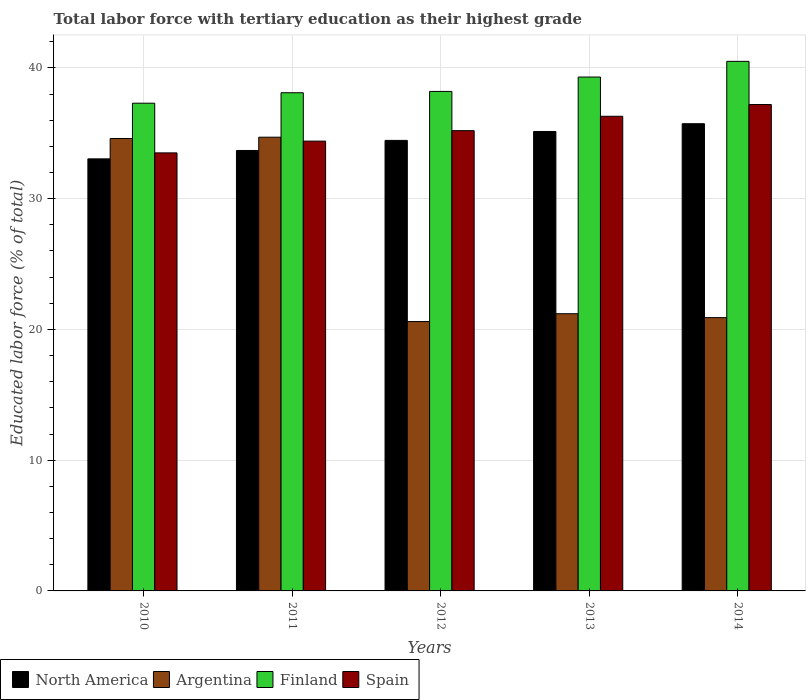How many groups of bars are there?
Keep it short and to the point. 5. Are the number of bars per tick equal to the number of legend labels?
Offer a terse response. Yes. How many bars are there on the 5th tick from the left?
Offer a terse response. 4. How many bars are there on the 3rd tick from the right?
Provide a short and direct response. 4. What is the label of the 3rd group of bars from the left?
Make the answer very short. 2012. What is the percentage of male labor force with tertiary education in North America in 2010?
Ensure brevity in your answer.  33.04. Across all years, what is the maximum percentage of male labor force with tertiary education in North America?
Provide a short and direct response. 35.73. Across all years, what is the minimum percentage of male labor force with tertiary education in North America?
Provide a short and direct response. 33.04. In which year was the percentage of male labor force with tertiary education in Finland minimum?
Make the answer very short. 2010. What is the total percentage of male labor force with tertiary education in North America in the graph?
Offer a terse response. 172.05. What is the difference between the percentage of male labor force with tertiary education in North America in 2010 and that in 2014?
Your response must be concise. -2.69. What is the difference between the percentage of male labor force with tertiary education in Finland in 2010 and the percentage of male labor force with tertiary education in Argentina in 2014?
Offer a terse response. 16.4. What is the average percentage of male labor force with tertiary education in Spain per year?
Your response must be concise. 35.32. In the year 2011, what is the difference between the percentage of male labor force with tertiary education in Argentina and percentage of male labor force with tertiary education in North America?
Offer a very short reply. 1.02. What is the ratio of the percentage of male labor force with tertiary education in Argentina in 2011 to that in 2012?
Give a very brief answer. 1.68. Is the percentage of male labor force with tertiary education in Spain in 2012 less than that in 2014?
Keep it short and to the point. Yes. Is the difference between the percentage of male labor force with tertiary education in Argentina in 2010 and 2012 greater than the difference between the percentage of male labor force with tertiary education in North America in 2010 and 2012?
Provide a short and direct response. Yes. What is the difference between the highest and the second highest percentage of male labor force with tertiary education in Argentina?
Provide a short and direct response. 0.1. What is the difference between the highest and the lowest percentage of male labor force with tertiary education in Argentina?
Make the answer very short. 14.1. In how many years, is the percentage of male labor force with tertiary education in Spain greater than the average percentage of male labor force with tertiary education in Spain taken over all years?
Give a very brief answer. 2. Is the sum of the percentage of male labor force with tertiary education in Finland in 2010 and 2011 greater than the maximum percentage of male labor force with tertiary education in Spain across all years?
Your answer should be compact. Yes. Is it the case that in every year, the sum of the percentage of male labor force with tertiary education in North America and percentage of male labor force with tertiary education in Finland is greater than the sum of percentage of male labor force with tertiary education in Spain and percentage of male labor force with tertiary education in Argentina?
Your answer should be very brief. Yes. What does the 2nd bar from the left in 2011 represents?
Provide a succinct answer. Argentina. Is it the case that in every year, the sum of the percentage of male labor force with tertiary education in Spain and percentage of male labor force with tertiary education in Argentina is greater than the percentage of male labor force with tertiary education in North America?
Give a very brief answer. Yes. How many bars are there?
Make the answer very short. 20. Are all the bars in the graph horizontal?
Make the answer very short. No. Are the values on the major ticks of Y-axis written in scientific E-notation?
Offer a terse response. No. Does the graph contain any zero values?
Make the answer very short. No. Where does the legend appear in the graph?
Offer a terse response. Bottom left. What is the title of the graph?
Your response must be concise. Total labor force with tertiary education as their highest grade. What is the label or title of the X-axis?
Provide a short and direct response. Years. What is the label or title of the Y-axis?
Your response must be concise. Educated labor force (% of total). What is the Educated labor force (% of total) of North America in 2010?
Provide a succinct answer. 33.04. What is the Educated labor force (% of total) in Argentina in 2010?
Offer a terse response. 34.6. What is the Educated labor force (% of total) in Finland in 2010?
Keep it short and to the point. 37.3. What is the Educated labor force (% of total) in Spain in 2010?
Offer a terse response. 33.5. What is the Educated labor force (% of total) of North America in 2011?
Offer a very short reply. 33.68. What is the Educated labor force (% of total) of Argentina in 2011?
Offer a very short reply. 34.7. What is the Educated labor force (% of total) in Finland in 2011?
Ensure brevity in your answer.  38.1. What is the Educated labor force (% of total) in Spain in 2011?
Ensure brevity in your answer.  34.4. What is the Educated labor force (% of total) in North America in 2012?
Make the answer very short. 34.45. What is the Educated labor force (% of total) in Argentina in 2012?
Your response must be concise. 20.6. What is the Educated labor force (% of total) in Finland in 2012?
Offer a terse response. 38.2. What is the Educated labor force (% of total) of Spain in 2012?
Ensure brevity in your answer.  35.2. What is the Educated labor force (% of total) in North America in 2013?
Your response must be concise. 35.14. What is the Educated labor force (% of total) of Argentina in 2013?
Your response must be concise. 21.2. What is the Educated labor force (% of total) in Finland in 2013?
Keep it short and to the point. 39.3. What is the Educated labor force (% of total) of Spain in 2013?
Your answer should be compact. 36.3. What is the Educated labor force (% of total) in North America in 2014?
Ensure brevity in your answer.  35.73. What is the Educated labor force (% of total) in Argentina in 2014?
Give a very brief answer. 20.9. What is the Educated labor force (% of total) in Finland in 2014?
Keep it short and to the point. 40.5. What is the Educated labor force (% of total) in Spain in 2014?
Your response must be concise. 37.2. Across all years, what is the maximum Educated labor force (% of total) of North America?
Give a very brief answer. 35.73. Across all years, what is the maximum Educated labor force (% of total) of Argentina?
Offer a very short reply. 34.7. Across all years, what is the maximum Educated labor force (% of total) in Finland?
Provide a succinct answer. 40.5. Across all years, what is the maximum Educated labor force (% of total) in Spain?
Offer a terse response. 37.2. Across all years, what is the minimum Educated labor force (% of total) in North America?
Give a very brief answer. 33.04. Across all years, what is the minimum Educated labor force (% of total) in Argentina?
Provide a short and direct response. 20.6. Across all years, what is the minimum Educated labor force (% of total) of Finland?
Ensure brevity in your answer.  37.3. Across all years, what is the minimum Educated labor force (% of total) in Spain?
Keep it short and to the point. 33.5. What is the total Educated labor force (% of total) of North America in the graph?
Offer a terse response. 172.05. What is the total Educated labor force (% of total) in Argentina in the graph?
Make the answer very short. 132. What is the total Educated labor force (% of total) in Finland in the graph?
Your answer should be very brief. 193.4. What is the total Educated labor force (% of total) in Spain in the graph?
Offer a very short reply. 176.6. What is the difference between the Educated labor force (% of total) in North America in 2010 and that in 2011?
Your answer should be very brief. -0.64. What is the difference between the Educated labor force (% of total) of North America in 2010 and that in 2012?
Offer a very short reply. -1.41. What is the difference between the Educated labor force (% of total) of Finland in 2010 and that in 2012?
Offer a very short reply. -0.9. What is the difference between the Educated labor force (% of total) of North America in 2010 and that in 2013?
Provide a short and direct response. -2.09. What is the difference between the Educated labor force (% of total) of Argentina in 2010 and that in 2013?
Give a very brief answer. 13.4. What is the difference between the Educated labor force (% of total) of Finland in 2010 and that in 2013?
Give a very brief answer. -2. What is the difference between the Educated labor force (% of total) of Spain in 2010 and that in 2013?
Ensure brevity in your answer.  -2.8. What is the difference between the Educated labor force (% of total) in North America in 2010 and that in 2014?
Provide a short and direct response. -2.69. What is the difference between the Educated labor force (% of total) of North America in 2011 and that in 2012?
Provide a succinct answer. -0.77. What is the difference between the Educated labor force (% of total) of Argentina in 2011 and that in 2012?
Offer a very short reply. 14.1. What is the difference between the Educated labor force (% of total) of Finland in 2011 and that in 2012?
Provide a short and direct response. -0.1. What is the difference between the Educated labor force (% of total) in North America in 2011 and that in 2013?
Provide a succinct answer. -1.45. What is the difference between the Educated labor force (% of total) in Argentina in 2011 and that in 2013?
Your answer should be compact. 13.5. What is the difference between the Educated labor force (% of total) of Finland in 2011 and that in 2013?
Your response must be concise. -1.2. What is the difference between the Educated labor force (% of total) of Spain in 2011 and that in 2013?
Your response must be concise. -1.9. What is the difference between the Educated labor force (% of total) in North America in 2011 and that in 2014?
Your answer should be compact. -2.05. What is the difference between the Educated labor force (% of total) in Argentina in 2011 and that in 2014?
Provide a succinct answer. 13.8. What is the difference between the Educated labor force (% of total) of Spain in 2011 and that in 2014?
Provide a short and direct response. -2.8. What is the difference between the Educated labor force (% of total) in North America in 2012 and that in 2013?
Offer a terse response. -0.68. What is the difference between the Educated labor force (% of total) in Finland in 2012 and that in 2013?
Your response must be concise. -1.1. What is the difference between the Educated labor force (% of total) in North America in 2012 and that in 2014?
Keep it short and to the point. -1.28. What is the difference between the Educated labor force (% of total) of Argentina in 2012 and that in 2014?
Offer a very short reply. -0.3. What is the difference between the Educated labor force (% of total) of Finland in 2012 and that in 2014?
Keep it short and to the point. -2.3. What is the difference between the Educated labor force (% of total) of Spain in 2012 and that in 2014?
Ensure brevity in your answer.  -2. What is the difference between the Educated labor force (% of total) of North America in 2013 and that in 2014?
Offer a very short reply. -0.59. What is the difference between the Educated labor force (% of total) of North America in 2010 and the Educated labor force (% of total) of Argentina in 2011?
Make the answer very short. -1.66. What is the difference between the Educated labor force (% of total) in North America in 2010 and the Educated labor force (% of total) in Finland in 2011?
Give a very brief answer. -5.06. What is the difference between the Educated labor force (% of total) in North America in 2010 and the Educated labor force (% of total) in Spain in 2011?
Keep it short and to the point. -1.36. What is the difference between the Educated labor force (% of total) of Argentina in 2010 and the Educated labor force (% of total) of Finland in 2011?
Give a very brief answer. -3.5. What is the difference between the Educated labor force (% of total) in North America in 2010 and the Educated labor force (% of total) in Argentina in 2012?
Ensure brevity in your answer.  12.44. What is the difference between the Educated labor force (% of total) of North America in 2010 and the Educated labor force (% of total) of Finland in 2012?
Your response must be concise. -5.16. What is the difference between the Educated labor force (% of total) in North America in 2010 and the Educated labor force (% of total) in Spain in 2012?
Provide a short and direct response. -2.16. What is the difference between the Educated labor force (% of total) of Argentina in 2010 and the Educated labor force (% of total) of Finland in 2012?
Ensure brevity in your answer.  -3.6. What is the difference between the Educated labor force (% of total) in Finland in 2010 and the Educated labor force (% of total) in Spain in 2012?
Ensure brevity in your answer.  2.1. What is the difference between the Educated labor force (% of total) in North America in 2010 and the Educated labor force (% of total) in Argentina in 2013?
Keep it short and to the point. 11.84. What is the difference between the Educated labor force (% of total) in North America in 2010 and the Educated labor force (% of total) in Finland in 2013?
Offer a very short reply. -6.26. What is the difference between the Educated labor force (% of total) of North America in 2010 and the Educated labor force (% of total) of Spain in 2013?
Provide a succinct answer. -3.26. What is the difference between the Educated labor force (% of total) of North America in 2010 and the Educated labor force (% of total) of Argentina in 2014?
Your response must be concise. 12.14. What is the difference between the Educated labor force (% of total) in North America in 2010 and the Educated labor force (% of total) in Finland in 2014?
Provide a succinct answer. -7.46. What is the difference between the Educated labor force (% of total) of North America in 2010 and the Educated labor force (% of total) of Spain in 2014?
Provide a short and direct response. -4.16. What is the difference between the Educated labor force (% of total) of Argentina in 2010 and the Educated labor force (% of total) of Spain in 2014?
Offer a terse response. -2.6. What is the difference between the Educated labor force (% of total) of Finland in 2010 and the Educated labor force (% of total) of Spain in 2014?
Offer a very short reply. 0.1. What is the difference between the Educated labor force (% of total) in North America in 2011 and the Educated labor force (% of total) in Argentina in 2012?
Make the answer very short. 13.08. What is the difference between the Educated labor force (% of total) of North America in 2011 and the Educated labor force (% of total) of Finland in 2012?
Give a very brief answer. -4.52. What is the difference between the Educated labor force (% of total) of North America in 2011 and the Educated labor force (% of total) of Spain in 2012?
Make the answer very short. -1.52. What is the difference between the Educated labor force (% of total) of Argentina in 2011 and the Educated labor force (% of total) of Spain in 2012?
Offer a very short reply. -0.5. What is the difference between the Educated labor force (% of total) of Finland in 2011 and the Educated labor force (% of total) of Spain in 2012?
Your response must be concise. 2.9. What is the difference between the Educated labor force (% of total) of North America in 2011 and the Educated labor force (% of total) of Argentina in 2013?
Your answer should be compact. 12.48. What is the difference between the Educated labor force (% of total) in North America in 2011 and the Educated labor force (% of total) in Finland in 2013?
Give a very brief answer. -5.62. What is the difference between the Educated labor force (% of total) in North America in 2011 and the Educated labor force (% of total) in Spain in 2013?
Keep it short and to the point. -2.62. What is the difference between the Educated labor force (% of total) in Argentina in 2011 and the Educated labor force (% of total) in Finland in 2013?
Offer a very short reply. -4.6. What is the difference between the Educated labor force (% of total) of North America in 2011 and the Educated labor force (% of total) of Argentina in 2014?
Offer a terse response. 12.78. What is the difference between the Educated labor force (% of total) of North America in 2011 and the Educated labor force (% of total) of Finland in 2014?
Offer a very short reply. -6.82. What is the difference between the Educated labor force (% of total) of North America in 2011 and the Educated labor force (% of total) of Spain in 2014?
Ensure brevity in your answer.  -3.52. What is the difference between the Educated labor force (% of total) in Argentina in 2011 and the Educated labor force (% of total) in Finland in 2014?
Your answer should be very brief. -5.8. What is the difference between the Educated labor force (% of total) of Argentina in 2011 and the Educated labor force (% of total) of Spain in 2014?
Make the answer very short. -2.5. What is the difference between the Educated labor force (% of total) of Finland in 2011 and the Educated labor force (% of total) of Spain in 2014?
Your answer should be compact. 0.9. What is the difference between the Educated labor force (% of total) of North America in 2012 and the Educated labor force (% of total) of Argentina in 2013?
Your answer should be very brief. 13.26. What is the difference between the Educated labor force (% of total) in North America in 2012 and the Educated labor force (% of total) in Finland in 2013?
Provide a short and direct response. -4.84. What is the difference between the Educated labor force (% of total) of North America in 2012 and the Educated labor force (% of total) of Spain in 2013?
Make the answer very short. -1.84. What is the difference between the Educated labor force (% of total) of Argentina in 2012 and the Educated labor force (% of total) of Finland in 2013?
Provide a short and direct response. -18.7. What is the difference between the Educated labor force (% of total) of Argentina in 2012 and the Educated labor force (% of total) of Spain in 2013?
Your answer should be very brief. -15.7. What is the difference between the Educated labor force (% of total) of North America in 2012 and the Educated labor force (% of total) of Argentina in 2014?
Your answer should be compact. 13.55. What is the difference between the Educated labor force (% of total) of North America in 2012 and the Educated labor force (% of total) of Finland in 2014?
Make the answer very short. -6.04. What is the difference between the Educated labor force (% of total) of North America in 2012 and the Educated labor force (% of total) of Spain in 2014?
Ensure brevity in your answer.  -2.75. What is the difference between the Educated labor force (% of total) in Argentina in 2012 and the Educated labor force (% of total) in Finland in 2014?
Provide a succinct answer. -19.9. What is the difference between the Educated labor force (% of total) of Argentina in 2012 and the Educated labor force (% of total) of Spain in 2014?
Provide a short and direct response. -16.6. What is the difference between the Educated labor force (% of total) of North America in 2013 and the Educated labor force (% of total) of Argentina in 2014?
Your answer should be very brief. 14.24. What is the difference between the Educated labor force (% of total) of North America in 2013 and the Educated labor force (% of total) of Finland in 2014?
Provide a short and direct response. -5.36. What is the difference between the Educated labor force (% of total) of North America in 2013 and the Educated labor force (% of total) of Spain in 2014?
Offer a terse response. -2.06. What is the difference between the Educated labor force (% of total) of Argentina in 2013 and the Educated labor force (% of total) of Finland in 2014?
Provide a short and direct response. -19.3. What is the difference between the Educated labor force (% of total) in Argentina in 2013 and the Educated labor force (% of total) in Spain in 2014?
Provide a succinct answer. -16. What is the average Educated labor force (% of total) in North America per year?
Provide a short and direct response. 34.41. What is the average Educated labor force (% of total) of Argentina per year?
Give a very brief answer. 26.4. What is the average Educated labor force (% of total) of Finland per year?
Give a very brief answer. 38.68. What is the average Educated labor force (% of total) in Spain per year?
Provide a succinct answer. 35.32. In the year 2010, what is the difference between the Educated labor force (% of total) of North America and Educated labor force (% of total) of Argentina?
Your response must be concise. -1.56. In the year 2010, what is the difference between the Educated labor force (% of total) in North America and Educated labor force (% of total) in Finland?
Offer a terse response. -4.26. In the year 2010, what is the difference between the Educated labor force (% of total) of North America and Educated labor force (% of total) of Spain?
Your response must be concise. -0.46. In the year 2010, what is the difference between the Educated labor force (% of total) of Argentina and Educated labor force (% of total) of Finland?
Offer a very short reply. -2.7. In the year 2010, what is the difference between the Educated labor force (% of total) of Argentina and Educated labor force (% of total) of Spain?
Give a very brief answer. 1.1. In the year 2010, what is the difference between the Educated labor force (% of total) of Finland and Educated labor force (% of total) of Spain?
Your answer should be very brief. 3.8. In the year 2011, what is the difference between the Educated labor force (% of total) in North America and Educated labor force (% of total) in Argentina?
Ensure brevity in your answer.  -1.02. In the year 2011, what is the difference between the Educated labor force (% of total) in North America and Educated labor force (% of total) in Finland?
Your answer should be very brief. -4.42. In the year 2011, what is the difference between the Educated labor force (% of total) of North America and Educated labor force (% of total) of Spain?
Your answer should be very brief. -0.72. In the year 2011, what is the difference between the Educated labor force (% of total) in Argentina and Educated labor force (% of total) in Spain?
Your answer should be very brief. 0.3. In the year 2012, what is the difference between the Educated labor force (% of total) of North America and Educated labor force (% of total) of Argentina?
Provide a succinct answer. 13.86. In the year 2012, what is the difference between the Educated labor force (% of total) of North America and Educated labor force (% of total) of Finland?
Your answer should be very brief. -3.75. In the year 2012, what is the difference between the Educated labor force (% of total) of North America and Educated labor force (% of total) of Spain?
Your response must be concise. -0.74. In the year 2012, what is the difference between the Educated labor force (% of total) of Argentina and Educated labor force (% of total) of Finland?
Your response must be concise. -17.6. In the year 2012, what is the difference between the Educated labor force (% of total) in Argentina and Educated labor force (% of total) in Spain?
Offer a very short reply. -14.6. In the year 2013, what is the difference between the Educated labor force (% of total) of North America and Educated labor force (% of total) of Argentina?
Provide a short and direct response. 13.94. In the year 2013, what is the difference between the Educated labor force (% of total) of North America and Educated labor force (% of total) of Finland?
Offer a very short reply. -4.16. In the year 2013, what is the difference between the Educated labor force (% of total) of North America and Educated labor force (% of total) of Spain?
Make the answer very short. -1.16. In the year 2013, what is the difference between the Educated labor force (% of total) of Argentina and Educated labor force (% of total) of Finland?
Provide a succinct answer. -18.1. In the year 2013, what is the difference between the Educated labor force (% of total) of Argentina and Educated labor force (% of total) of Spain?
Your answer should be compact. -15.1. In the year 2014, what is the difference between the Educated labor force (% of total) in North America and Educated labor force (% of total) in Argentina?
Offer a very short reply. 14.83. In the year 2014, what is the difference between the Educated labor force (% of total) of North America and Educated labor force (% of total) of Finland?
Your answer should be compact. -4.77. In the year 2014, what is the difference between the Educated labor force (% of total) of North America and Educated labor force (% of total) of Spain?
Your answer should be very brief. -1.47. In the year 2014, what is the difference between the Educated labor force (% of total) of Argentina and Educated labor force (% of total) of Finland?
Provide a short and direct response. -19.6. In the year 2014, what is the difference between the Educated labor force (% of total) in Argentina and Educated labor force (% of total) in Spain?
Keep it short and to the point. -16.3. In the year 2014, what is the difference between the Educated labor force (% of total) in Finland and Educated labor force (% of total) in Spain?
Offer a terse response. 3.3. What is the ratio of the Educated labor force (% of total) in Spain in 2010 to that in 2011?
Offer a very short reply. 0.97. What is the ratio of the Educated labor force (% of total) of North America in 2010 to that in 2012?
Your answer should be very brief. 0.96. What is the ratio of the Educated labor force (% of total) in Argentina in 2010 to that in 2012?
Your answer should be very brief. 1.68. What is the ratio of the Educated labor force (% of total) of Finland in 2010 to that in 2012?
Give a very brief answer. 0.98. What is the ratio of the Educated labor force (% of total) of Spain in 2010 to that in 2012?
Keep it short and to the point. 0.95. What is the ratio of the Educated labor force (% of total) in North America in 2010 to that in 2013?
Keep it short and to the point. 0.94. What is the ratio of the Educated labor force (% of total) of Argentina in 2010 to that in 2013?
Provide a succinct answer. 1.63. What is the ratio of the Educated labor force (% of total) of Finland in 2010 to that in 2013?
Provide a succinct answer. 0.95. What is the ratio of the Educated labor force (% of total) of Spain in 2010 to that in 2013?
Provide a succinct answer. 0.92. What is the ratio of the Educated labor force (% of total) of North America in 2010 to that in 2014?
Your answer should be compact. 0.92. What is the ratio of the Educated labor force (% of total) of Argentina in 2010 to that in 2014?
Make the answer very short. 1.66. What is the ratio of the Educated labor force (% of total) of Finland in 2010 to that in 2014?
Offer a very short reply. 0.92. What is the ratio of the Educated labor force (% of total) in Spain in 2010 to that in 2014?
Your answer should be compact. 0.9. What is the ratio of the Educated labor force (% of total) in North America in 2011 to that in 2012?
Ensure brevity in your answer.  0.98. What is the ratio of the Educated labor force (% of total) of Argentina in 2011 to that in 2012?
Provide a succinct answer. 1.68. What is the ratio of the Educated labor force (% of total) in Finland in 2011 to that in 2012?
Keep it short and to the point. 1. What is the ratio of the Educated labor force (% of total) in Spain in 2011 to that in 2012?
Your answer should be very brief. 0.98. What is the ratio of the Educated labor force (% of total) in North America in 2011 to that in 2013?
Your answer should be very brief. 0.96. What is the ratio of the Educated labor force (% of total) in Argentina in 2011 to that in 2013?
Offer a very short reply. 1.64. What is the ratio of the Educated labor force (% of total) of Finland in 2011 to that in 2013?
Your response must be concise. 0.97. What is the ratio of the Educated labor force (% of total) of Spain in 2011 to that in 2013?
Ensure brevity in your answer.  0.95. What is the ratio of the Educated labor force (% of total) of North America in 2011 to that in 2014?
Provide a short and direct response. 0.94. What is the ratio of the Educated labor force (% of total) in Argentina in 2011 to that in 2014?
Your response must be concise. 1.66. What is the ratio of the Educated labor force (% of total) in Finland in 2011 to that in 2014?
Your response must be concise. 0.94. What is the ratio of the Educated labor force (% of total) of Spain in 2011 to that in 2014?
Offer a terse response. 0.92. What is the ratio of the Educated labor force (% of total) in North America in 2012 to that in 2013?
Keep it short and to the point. 0.98. What is the ratio of the Educated labor force (% of total) of Argentina in 2012 to that in 2013?
Offer a terse response. 0.97. What is the ratio of the Educated labor force (% of total) in Finland in 2012 to that in 2013?
Keep it short and to the point. 0.97. What is the ratio of the Educated labor force (% of total) in Spain in 2012 to that in 2013?
Give a very brief answer. 0.97. What is the ratio of the Educated labor force (% of total) in Argentina in 2012 to that in 2014?
Make the answer very short. 0.99. What is the ratio of the Educated labor force (% of total) of Finland in 2012 to that in 2014?
Provide a short and direct response. 0.94. What is the ratio of the Educated labor force (% of total) in Spain in 2012 to that in 2014?
Offer a terse response. 0.95. What is the ratio of the Educated labor force (% of total) in North America in 2013 to that in 2014?
Ensure brevity in your answer.  0.98. What is the ratio of the Educated labor force (% of total) of Argentina in 2013 to that in 2014?
Provide a short and direct response. 1.01. What is the ratio of the Educated labor force (% of total) of Finland in 2013 to that in 2014?
Make the answer very short. 0.97. What is the ratio of the Educated labor force (% of total) in Spain in 2013 to that in 2014?
Your response must be concise. 0.98. What is the difference between the highest and the second highest Educated labor force (% of total) of North America?
Your answer should be very brief. 0.59. What is the difference between the highest and the second highest Educated labor force (% of total) of Spain?
Offer a terse response. 0.9. What is the difference between the highest and the lowest Educated labor force (% of total) in North America?
Provide a succinct answer. 2.69. What is the difference between the highest and the lowest Educated labor force (% of total) in Finland?
Give a very brief answer. 3.2. What is the difference between the highest and the lowest Educated labor force (% of total) in Spain?
Your answer should be compact. 3.7. 